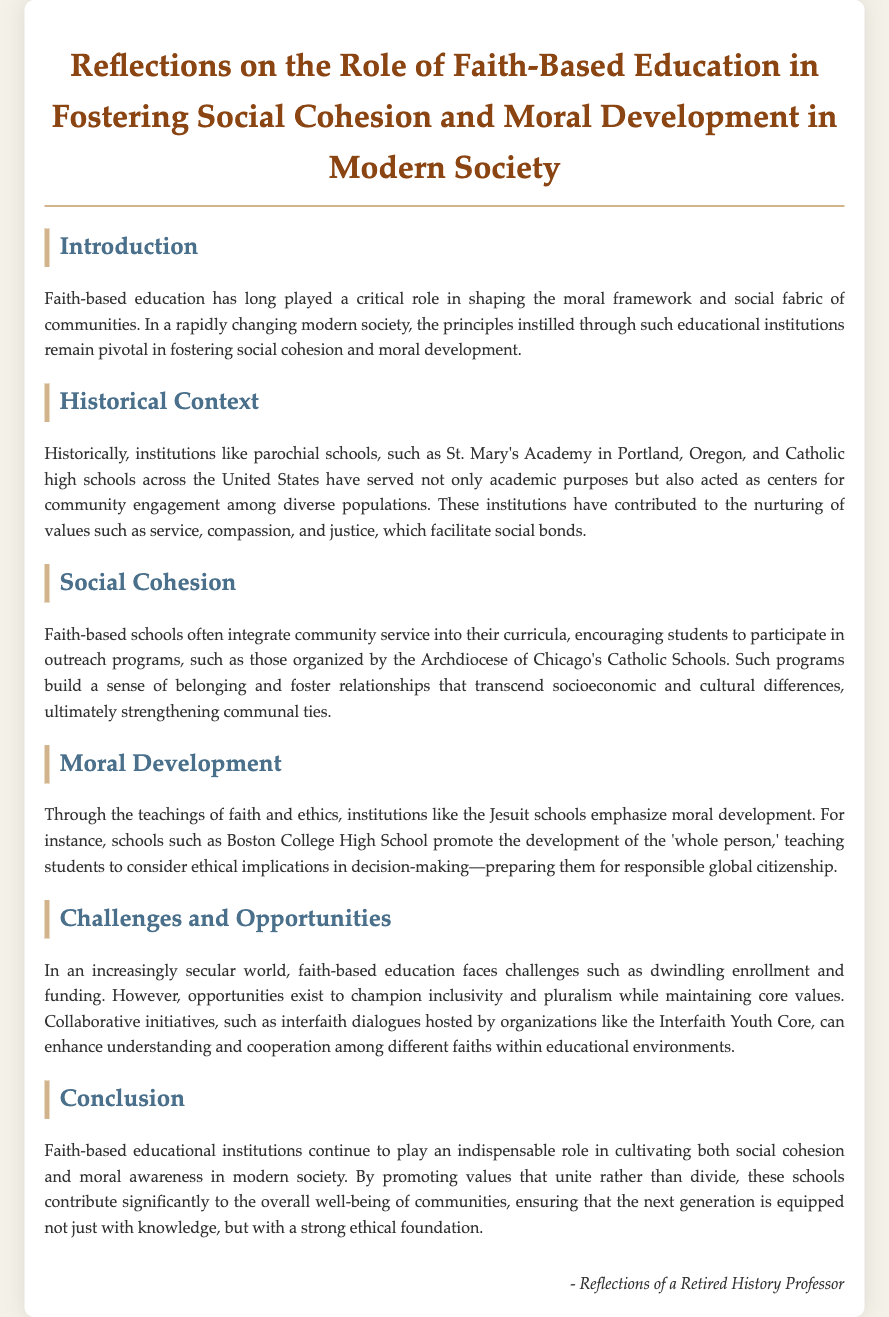What role has faith-based education played historically? Faith-based education has shaped the moral framework and social fabric of communities.
Answer: Shaping moral framework and social fabric Which school is mentioned as an example of a parochial school? St. Mary's Academy in Portland, Oregon is specifically mentioned as an example.
Answer: St. Mary's Academy What values do these institutions nurture according to the document? The document states that faith-based institutions nurture values such as service, compassion, and justice.
Answer: Service, compassion, and justice What current challenge is mentioned regarding faith-based education? The document highlights dwindling enrollment as a current challenge facing faith-based education.
Answer: Dwindling enrollment What does Boston College High School promote? The school promotes the development of the 'whole person.'
Answer: Development of the 'whole person' What type of initiatives can enhance understanding among different faiths? Collaborative initiatives like interfaith dialogues are mentioned as ways to enhance understanding.
Answer: Interfaith dialogues What is the main purpose of community service in faith-based schools? Community service aims to build a sense of belonging and foster relationships.
Answer: Build a sense of belonging How does the document conclude regarding faith-based education? The conclusion states that such institutions contribute significantly to the overall well-being of communities.
Answer: Contribute significantly to the overall well-being of communities 